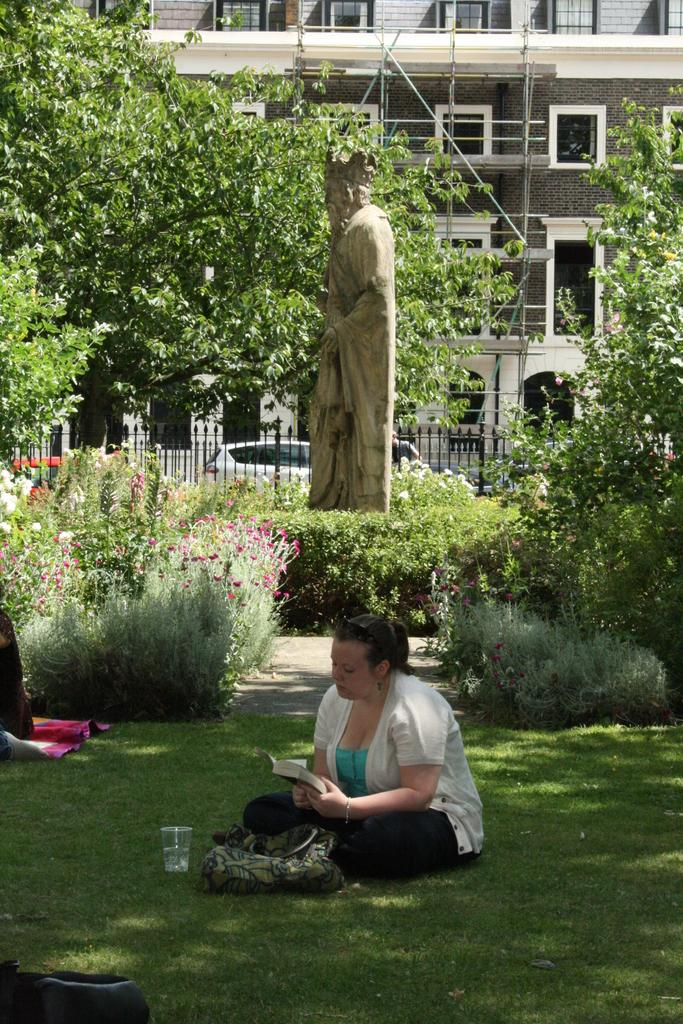What is the woman in the image doing? The woman is sitting on a grassland. What is the woman holding in her hand? The woman is holding a book in her hand. What can be seen in the background of the image? There are plants, trees, a statue, a railing, a car, and a building in the background of the image. What type of pipe is the woman smoking in the image? There is no pipe present in the image; the woman is holding a book. What scent can be detected from the woman in the image? There is no information about the scent of the woman in the image. 